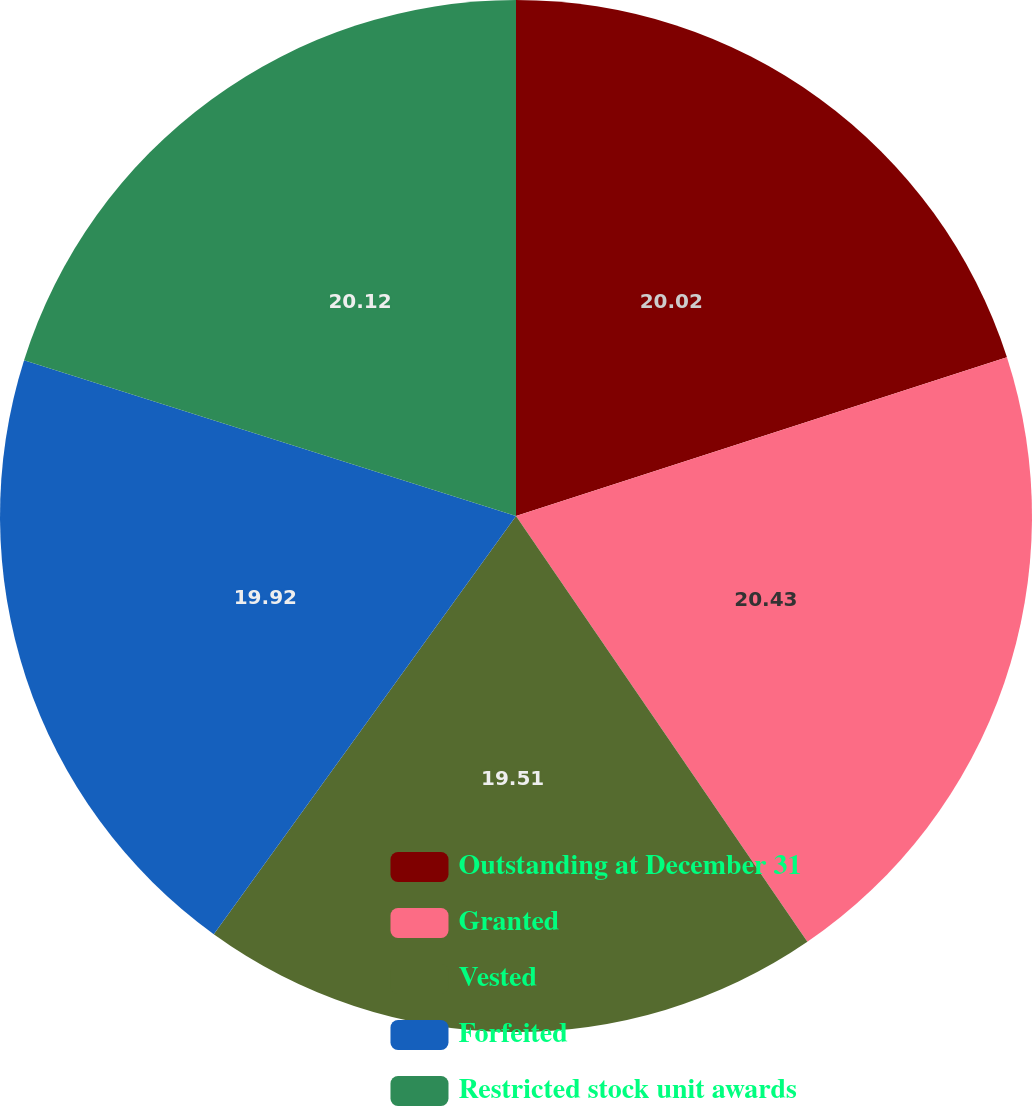Convert chart. <chart><loc_0><loc_0><loc_500><loc_500><pie_chart><fcel>Outstanding at December 31<fcel>Granted<fcel>Vested<fcel>Forfeited<fcel>Restricted stock unit awards<nl><fcel>20.02%<fcel>20.43%<fcel>19.51%<fcel>19.92%<fcel>20.12%<nl></chart> 